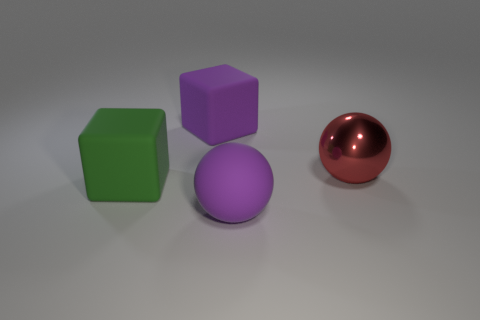Do the purple block and the red sphere have the same material?
Your response must be concise. No. How many big matte spheres are to the left of the matte cube left of the purple block?
Your answer should be very brief. 0. Is there a big matte object of the same shape as the big red shiny object?
Offer a very short reply. Yes. Do the red metal object that is on the right side of the big green object and the rubber thing that is to the left of the large purple cube have the same shape?
Give a very brief answer. No. The thing that is in front of the big purple block and on the left side of the big rubber ball has what shape?
Keep it short and to the point. Cube. Is there a cyan rubber thing of the same size as the green thing?
Offer a terse response. No. There is a shiny object; is it the same color as the object that is behind the red metallic sphere?
Your answer should be compact. No. What is the big purple cube made of?
Offer a terse response. Rubber. There is a large cube in front of the purple rubber block; what color is it?
Your answer should be compact. Green. How many cubes are the same color as the matte ball?
Offer a terse response. 1. 